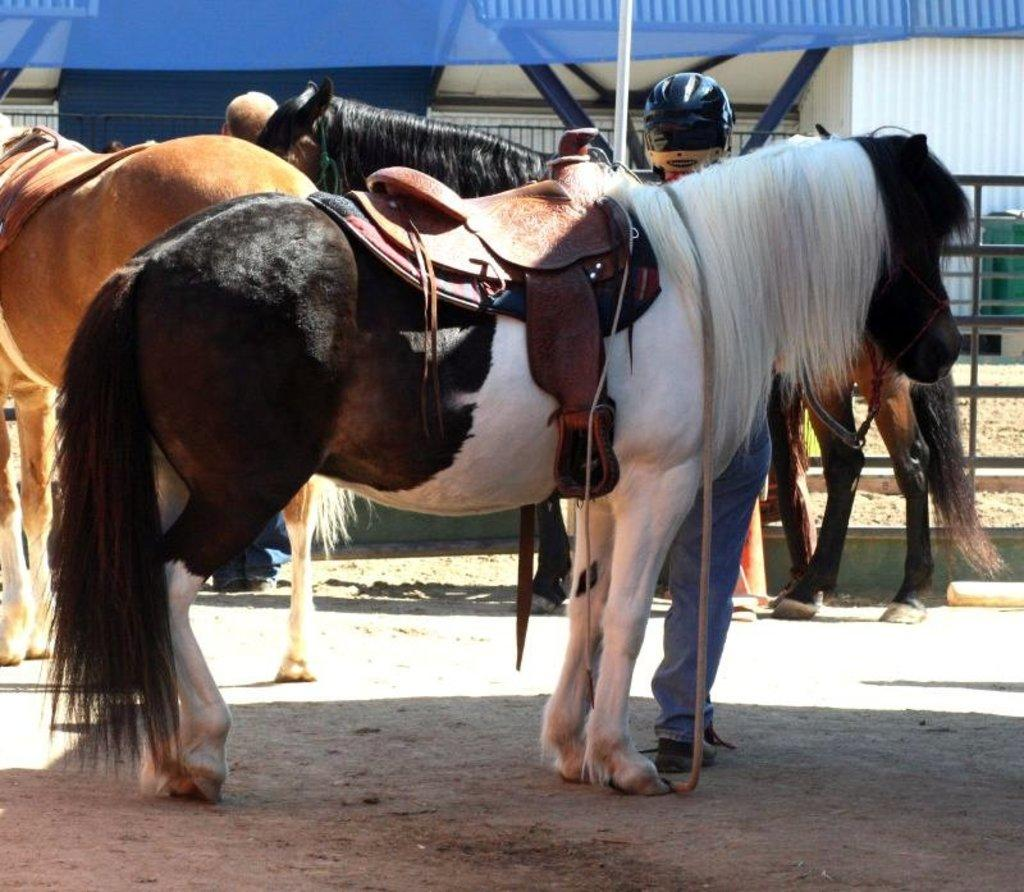How many horses are in the image? There are three horses in the image. What is the person on the ground doing in the image? The question cannot be definitively answered from the provided facts. What can be seen in the background of the image? There are tents and a fence in the background of the image. What is the weather like in the image? The image appears to have been taken during a sunny day. What type of appliance is being used by the horses in the image? There is no appliance present in the image; it features three horses and a person on the ground. What kind of pest can be seen crawling on the tents in the image? There is no pest visible in the image; it only shows horses, a person, tents, and a fence. 